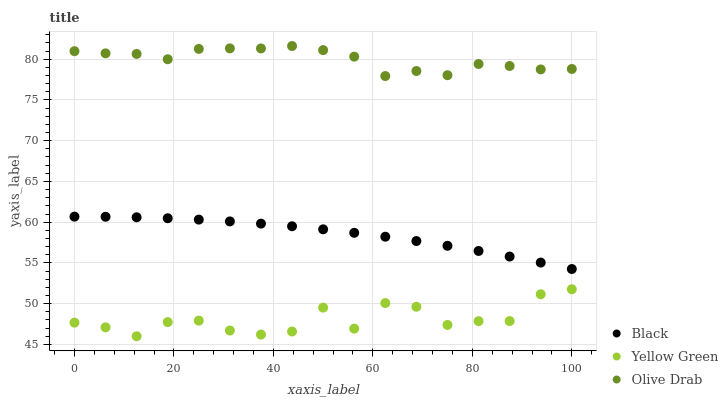Does Yellow Green have the minimum area under the curve?
Answer yes or no. Yes. Does Olive Drab have the maximum area under the curve?
Answer yes or no. Yes. Does Olive Drab have the minimum area under the curve?
Answer yes or no. No. Does Yellow Green have the maximum area under the curve?
Answer yes or no. No. Is Black the smoothest?
Answer yes or no. Yes. Is Yellow Green the roughest?
Answer yes or no. Yes. Is Olive Drab the smoothest?
Answer yes or no. No. Is Olive Drab the roughest?
Answer yes or no. No. Does Yellow Green have the lowest value?
Answer yes or no. Yes. Does Olive Drab have the lowest value?
Answer yes or no. No. Does Olive Drab have the highest value?
Answer yes or no. Yes. Does Yellow Green have the highest value?
Answer yes or no. No. Is Yellow Green less than Olive Drab?
Answer yes or no. Yes. Is Black greater than Yellow Green?
Answer yes or no. Yes. Does Yellow Green intersect Olive Drab?
Answer yes or no. No. 